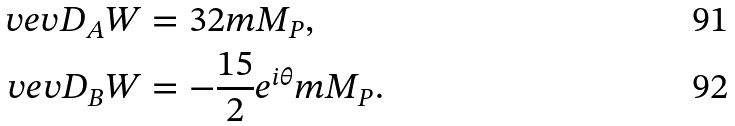Convert formula to latex. <formula><loc_0><loc_0><loc_500><loc_500>\ v e v { D _ { A } W } & = 3 2 m M _ { P } , \\ \ v e v { D _ { B } W } & = - \frac { 1 5 } { 2 } e ^ { i \theta } m M _ { P } .</formula> 